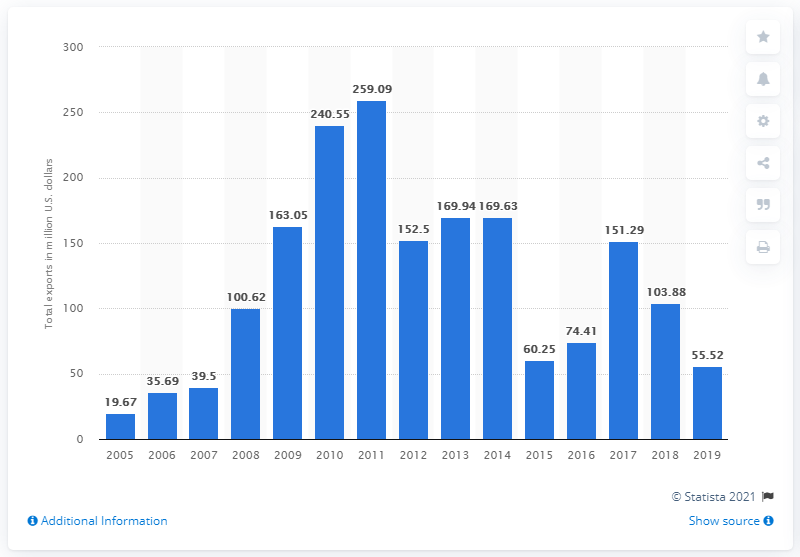Highlight a few significant elements in this photo. In 2019, the United States exported $55.52 million worth of merchandise to Paraguay. 